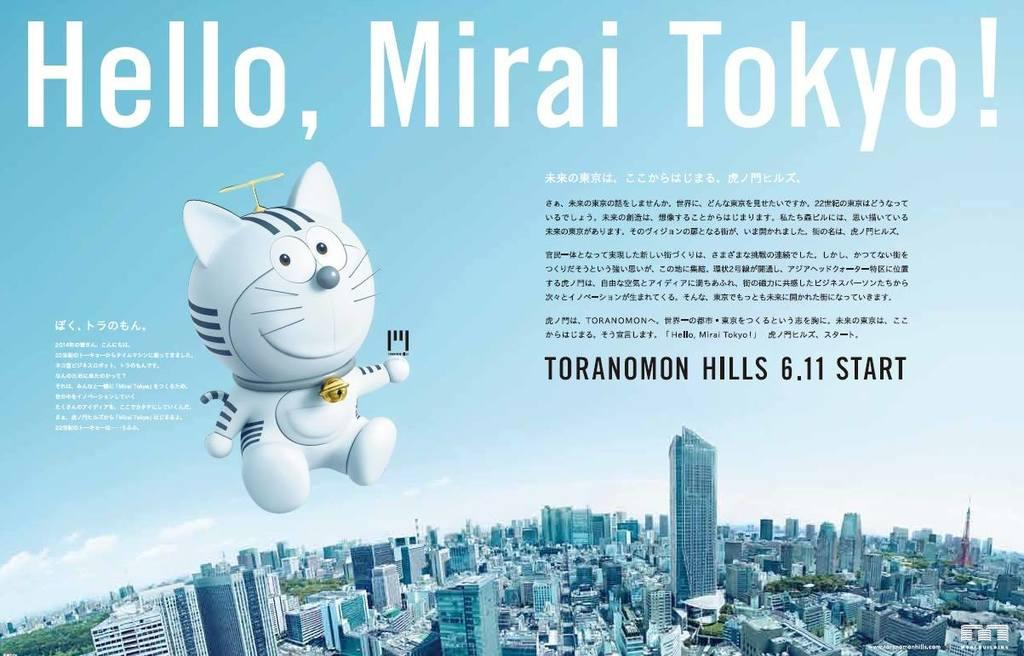What is the main subject of the poster in the image? The poster contains images of buildings, trees, and a cartoon image. What type of images are present on the poster? The poster contains images of buildings, trees, and a cartoon image. What other elements are present on the poster besides images? The poster contains text and depicts the sky. Can you tell me how many squares are depicted in the cartoon image on the poster? There is no mention of squares in the image or the provided facts, so it is impossible to determine the number of squares in the cartoon image. What type of jelly can be seen in the cartoon image on the poster? There is no jelly present in the image or the provided facts, so it is impossible to determine if there is any jelly in the cartoon image. 